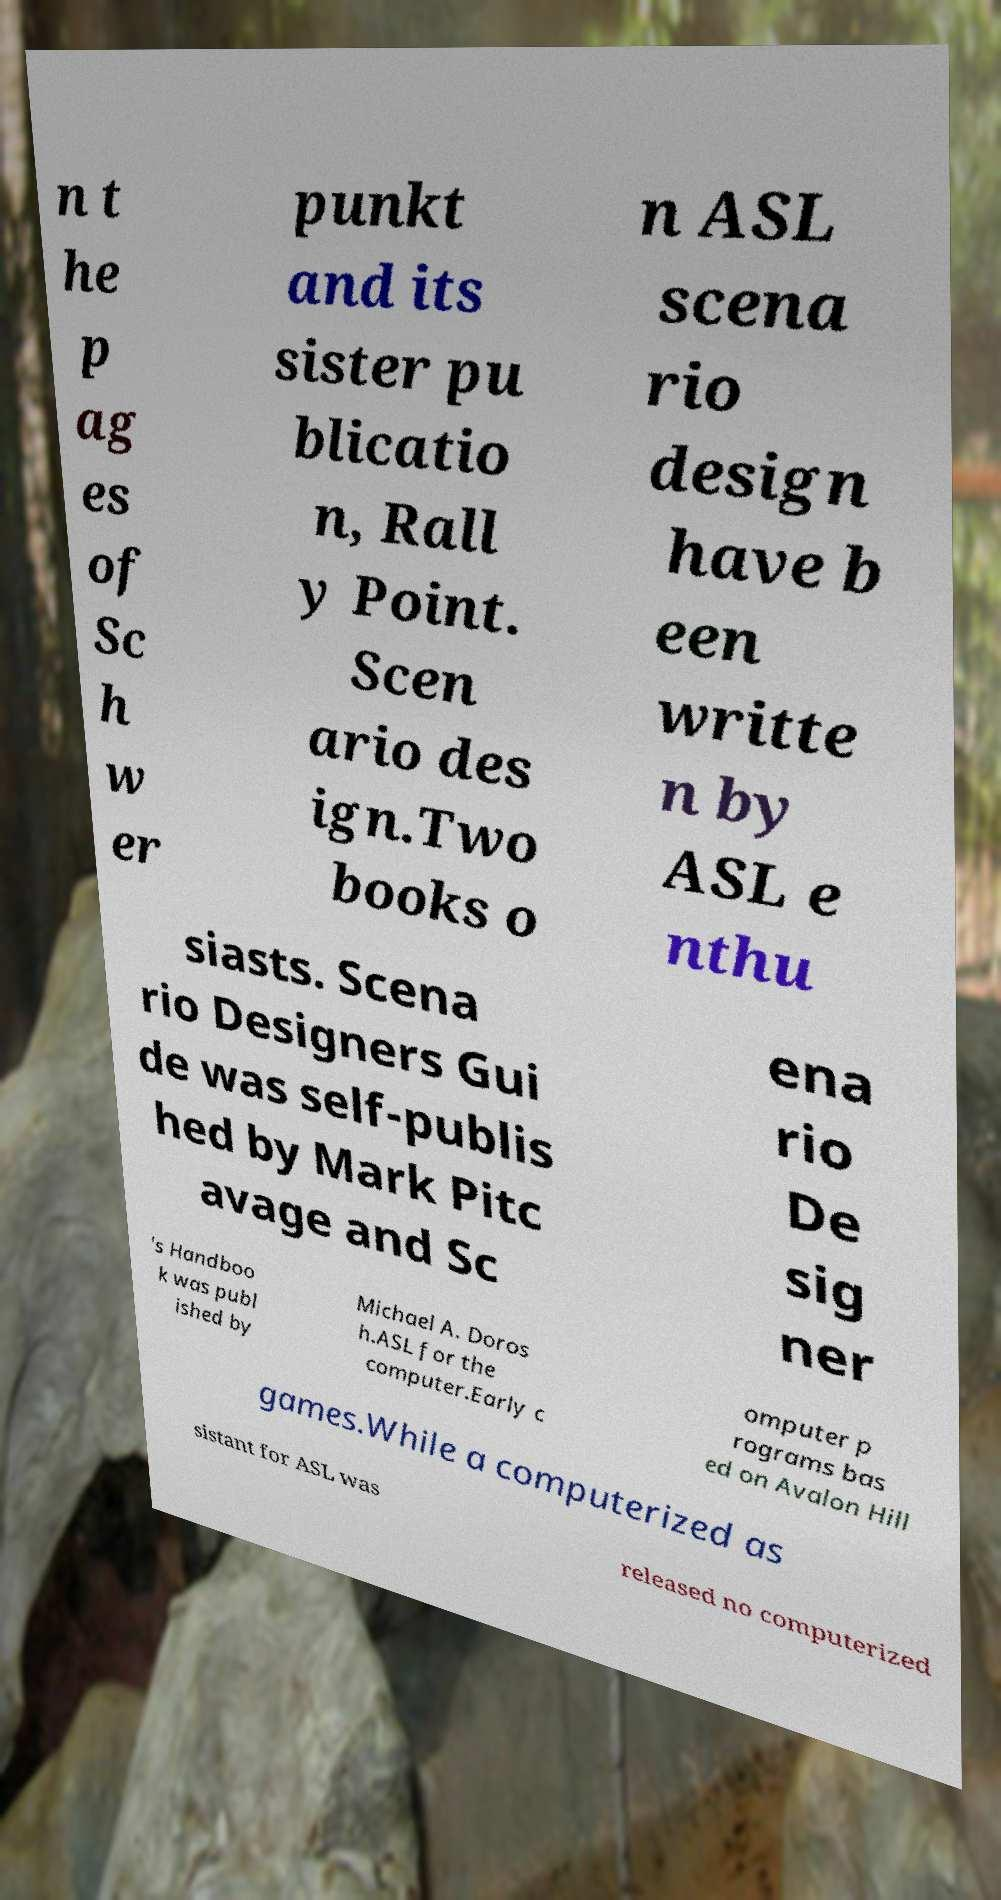Could you extract and type out the text from this image? n t he p ag es of Sc h w er punkt and its sister pu blicatio n, Rall y Point. Scen ario des ign.Two books o n ASL scena rio design have b een writte n by ASL e nthu siasts. Scena rio Designers Gui de was self-publis hed by Mark Pitc avage and Sc ena rio De sig ner 's Handboo k was publ ished by Michael A. Doros h.ASL for the computer.Early c omputer p rograms bas ed on Avalon Hill games.While a computerized as sistant for ASL was released no computerized 